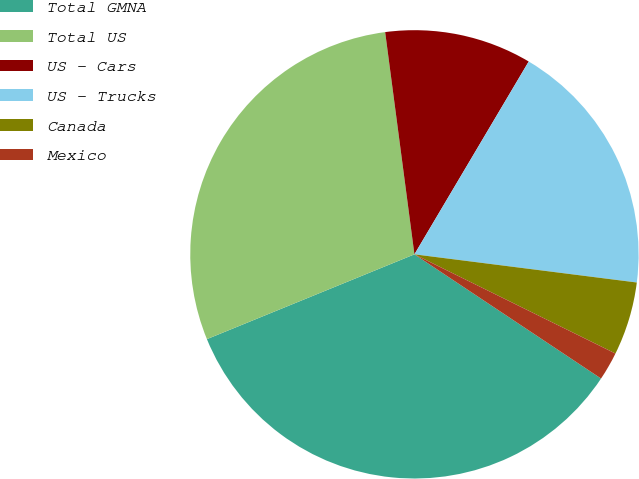Convert chart. <chart><loc_0><loc_0><loc_500><loc_500><pie_chart><fcel>Total GMNA<fcel>Total US<fcel>US - Cars<fcel>US - Trucks<fcel>Canada<fcel>Mexico<nl><fcel>34.48%<fcel>29.09%<fcel>10.6%<fcel>18.49%<fcel>5.29%<fcel>2.05%<nl></chart> 